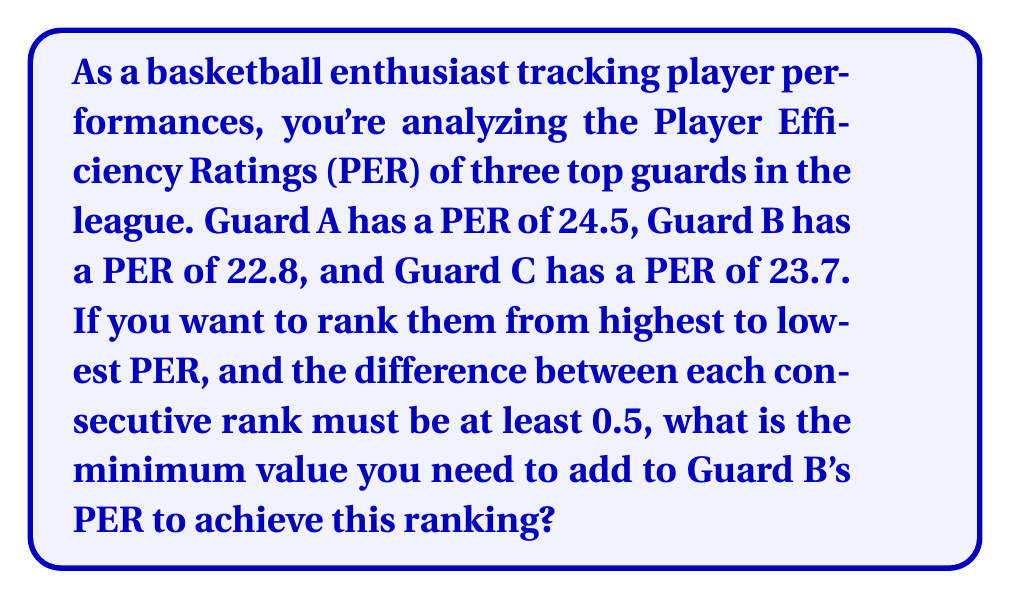Provide a solution to this math problem. Let's approach this step-by-step:

1) First, let's order the PERs from highest to lowest:
   Guard A: 24.5
   Guard C: 23.7
   Guard B: 22.8

2) For Guard B to be ranked above Guard C, their PER needs to be at least 0.5 higher than Guard C's PER.

3) Let $x$ be the value we need to add to Guard B's PER. We can set up the inequality:

   $22.8 + x \geq 23.7 + 0.5$

4) Simplify the right side:

   $22.8 + x \geq 24.2$

5) Subtract 22.8 from both sides:

   $x \geq 1.4$

6) Therefore, we need to add at least 1.4 to Guard B's PER to rank them above Guard C with a difference of at least 0.5.

7) Let's verify if this also satisfies the condition for ranking below Guard A:

   $24.5 - (22.8 + 1.4) = 0.3$

   This is less than 0.5, so we need to increase $x$ further.

8) To be exactly 0.5 below Guard A:

   $24.5 - (22.8 + x) = 0.5$

9) Solve for $x$:

   $1.7 = x$

Therefore, the minimum value we need to add to Guard B's PER is 1.7.
Answer: $1.7$ 